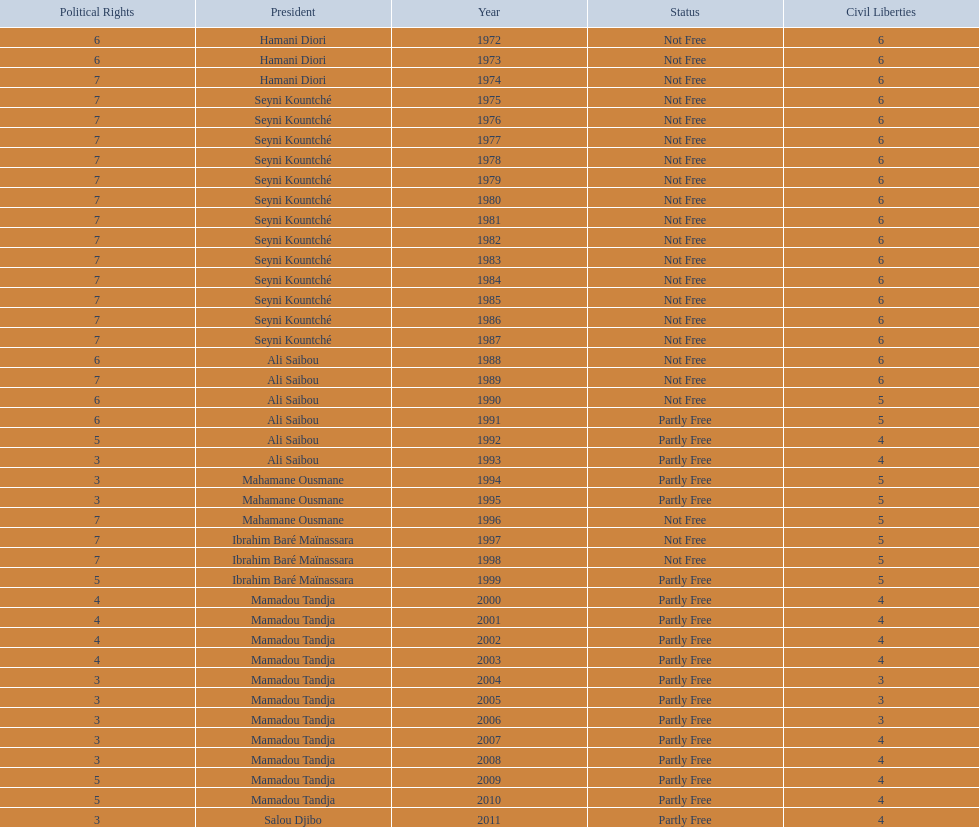For how long did ali saibou serve as president? 6. 